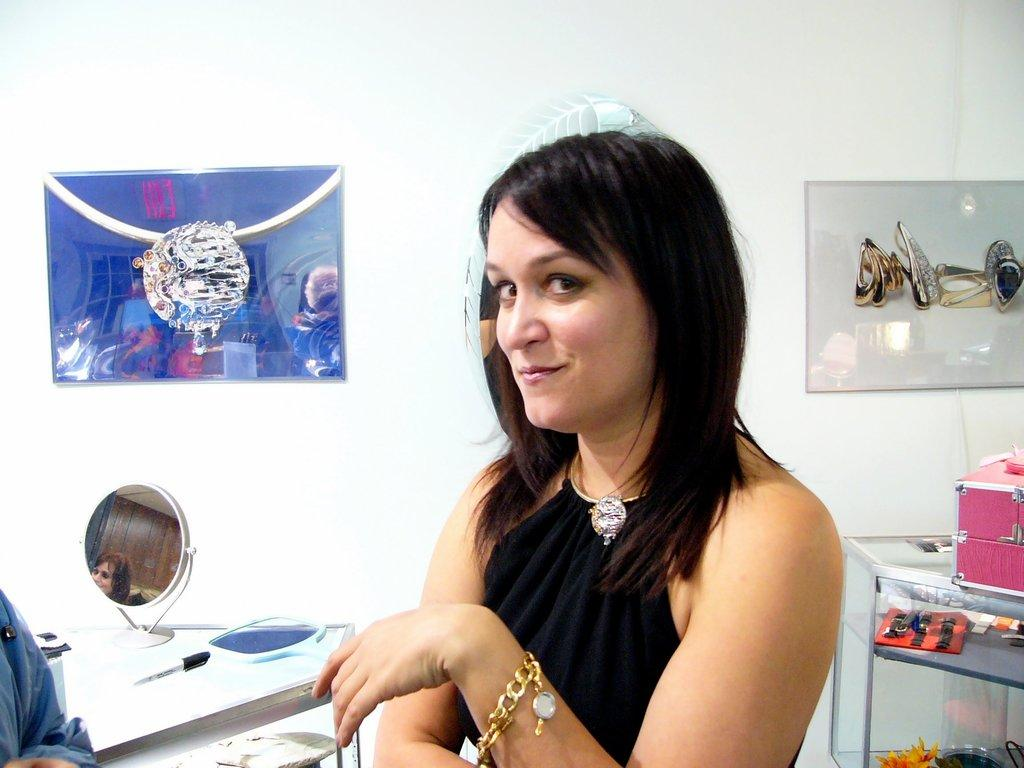Who is present in the image? There is a woman in the image. What is the woman doing in the image? The woman is smiling in the image. What objects can be seen in the image? There are mirrors, a box, and other objects in the image. Can you describe the background of the image? There are frames on the wall in the background of the image. How many people are present in the image? There is one person, a woman, present in the image. What type of club does the woman belong to in the image? There is no indication in the image that the woman belongs to any club. Can you see a robin in the image? No, there is no robin present in the image. 